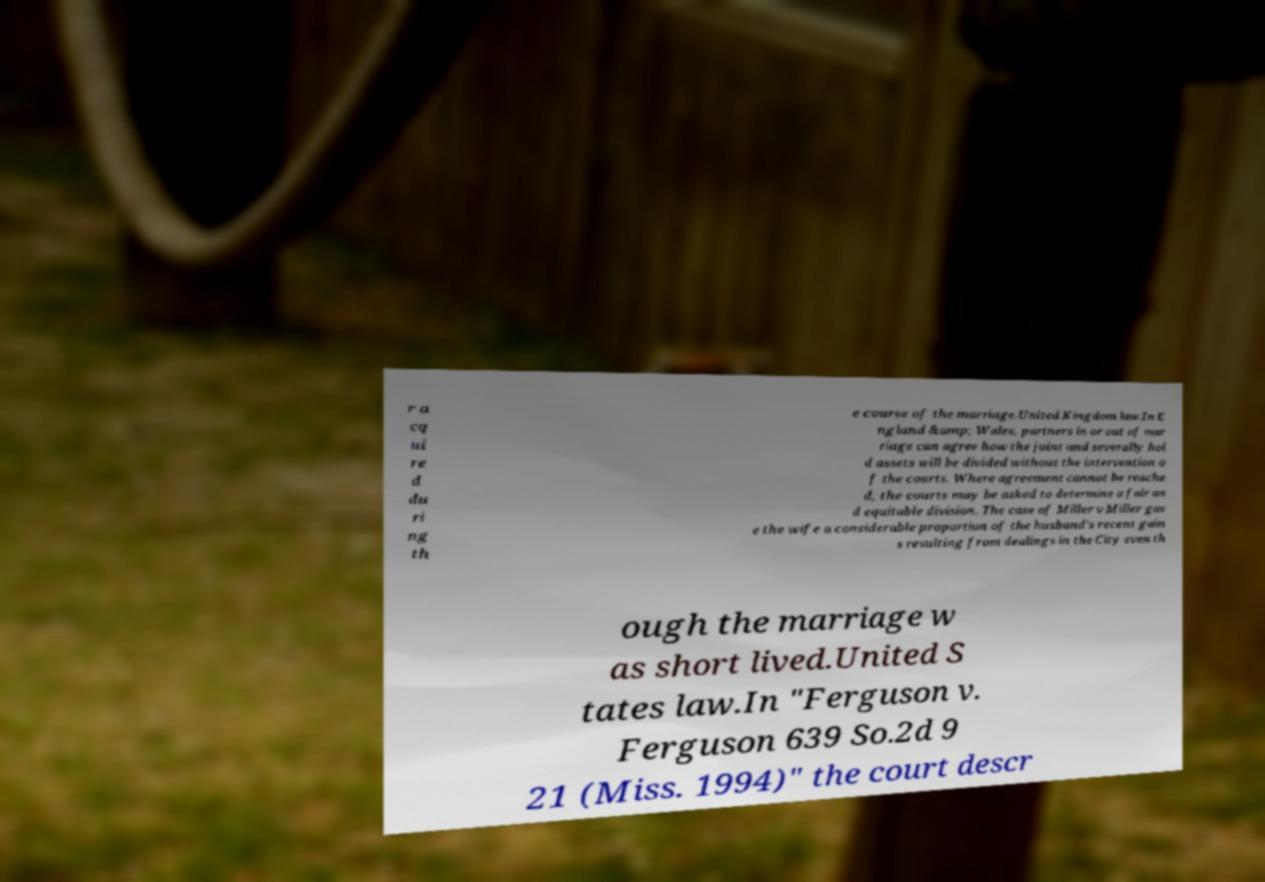I need the written content from this picture converted into text. Can you do that? r a cq ui re d du ri ng th e course of the marriage.United Kingdom law.In E ngland &amp; Wales, partners in or out of mar riage can agree how the joint and severally hol d assets will be divided without the intervention o f the courts. Where agreement cannot be reache d, the courts may be asked to determine a fair an d equitable division. The case of Miller v Miller gav e the wife a considerable proportion of the husband's recent gain s resulting from dealings in the City even th ough the marriage w as short lived.United S tates law.In "Ferguson v. Ferguson 639 So.2d 9 21 (Miss. 1994)" the court descr 